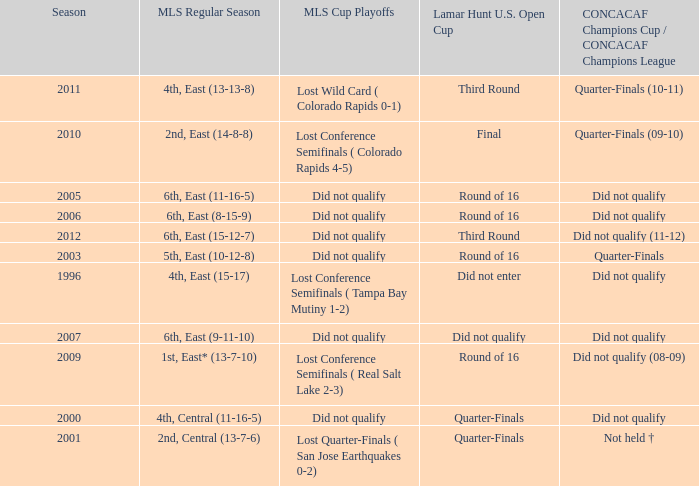What was the mls cup playoffs when concacaf champions cup / concacaf champions league was quarter-finals (09-10)? Lost Conference Semifinals ( Colorado Rapids 4-5). 